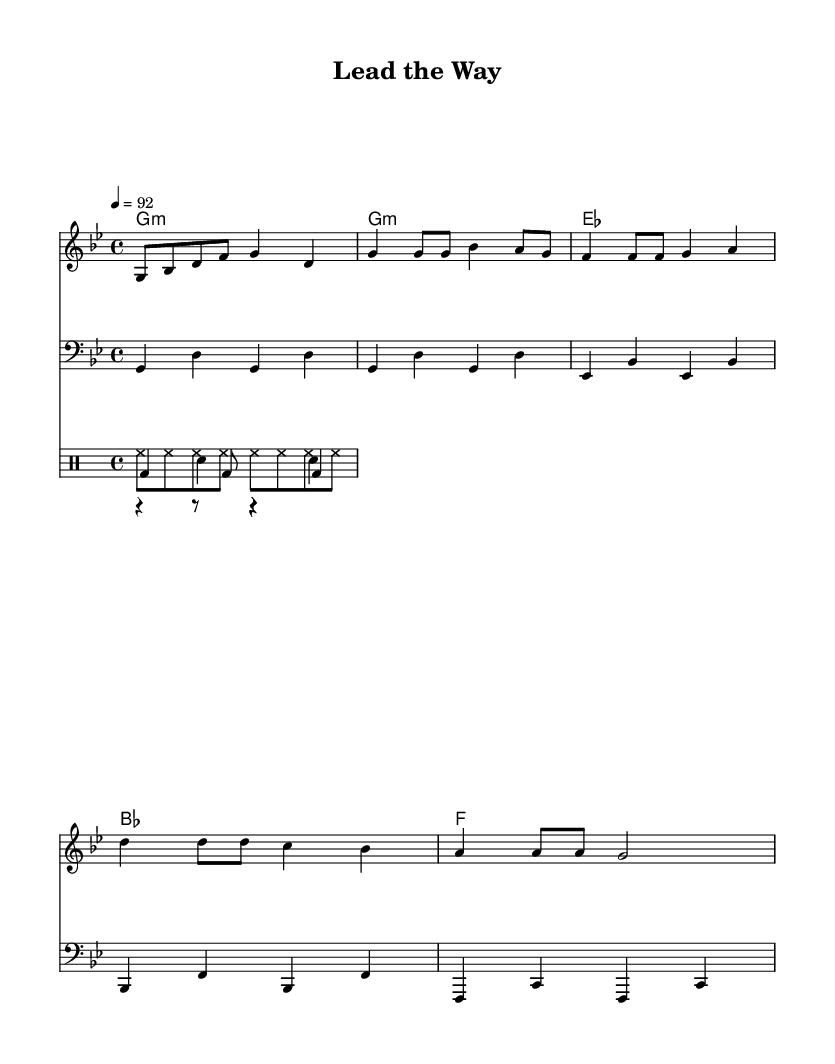What is the key signature of this music? The key signature is G minor, which has two flats (B flat and E flat). This is deduced from the presence of the "g" key noted in the header section of the code, identifying G minor as the tonal center.
Answer: G minor What is the time signature of this piece? The time signature is 4/4, which means there are four beats in a measure and the quarter note gets one beat. This is indicated in the global section of the code with the "time" instruction setting it to 4/4.
Answer: 4/4 What is the tempo marking for this rap piece? The tempo marking is 92 beats per minute, indicating the speed of the piece. This is stated in the global section of the code where it specifically mentions "tempo 4 = 92."
Answer: 92 How many measures are in the chorus? The chorus has 4 measures, as indicated in the music formatted under the chorus section where there are 4 distinct groupings of music notes within the specified chorus lyrics.
Answer: 4 What is the first lyric in the verse? The first lyric in the verse is "Stand up tall", as defined in the verseOneLyrics section. The lyrics follow the melody from that point.
Answer: Stand up tall What drum pattern is featured in this piece? The drum pattern features a kick drum, snare drum, and hi-hat, indicated by the presence of specific rhythmic notations for each kind of drum in their respective sections. This combination is common in rap music for maintaining a steady and engaging beat.
Answer: Kick, snare, hi-hat What is a main theme expressed in the lyrics? A main theme expressed in the lyrics is leadership and inspiration, evident from phrases like "Lead the way" which encourage the listener to take charge and inspire others. The structure of the lyrics emphasizes motivating behavior.
Answer: Leadership and inspiration 